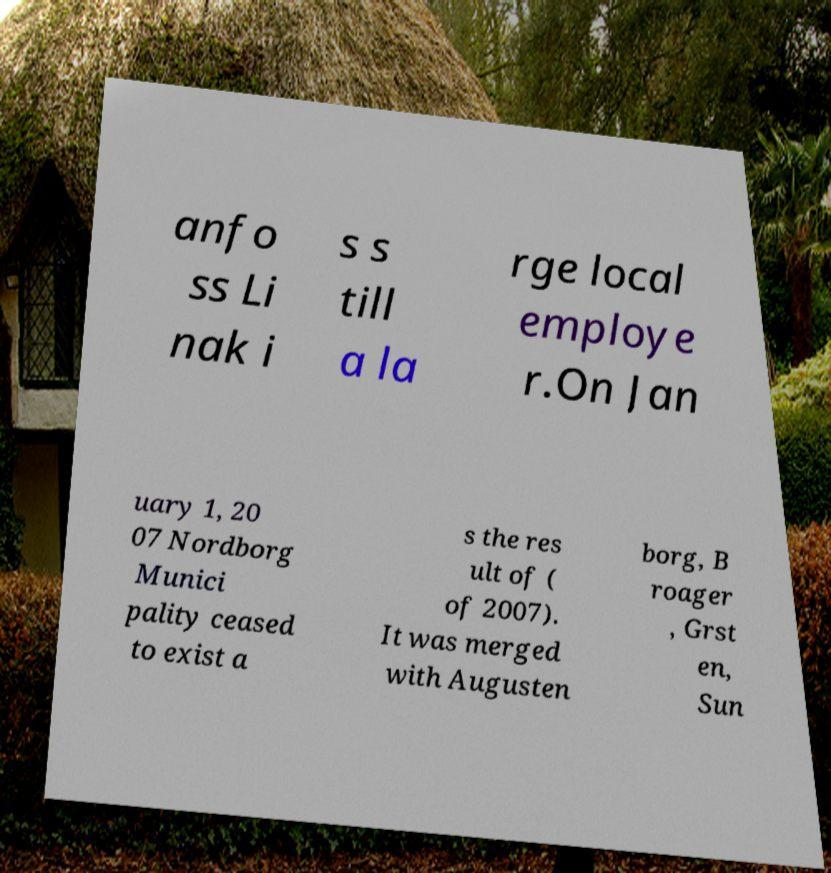There's text embedded in this image that I need extracted. Can you transcribe it verbatim? anfo ss Li nak i s s till a la rge local employe r.On Jan uary 1, 20 07 Nordborg Munici pality ceased to exist a s the res ult of ( of 2007). It was merged with Augusten borg, B roager , Grst en, Sun 